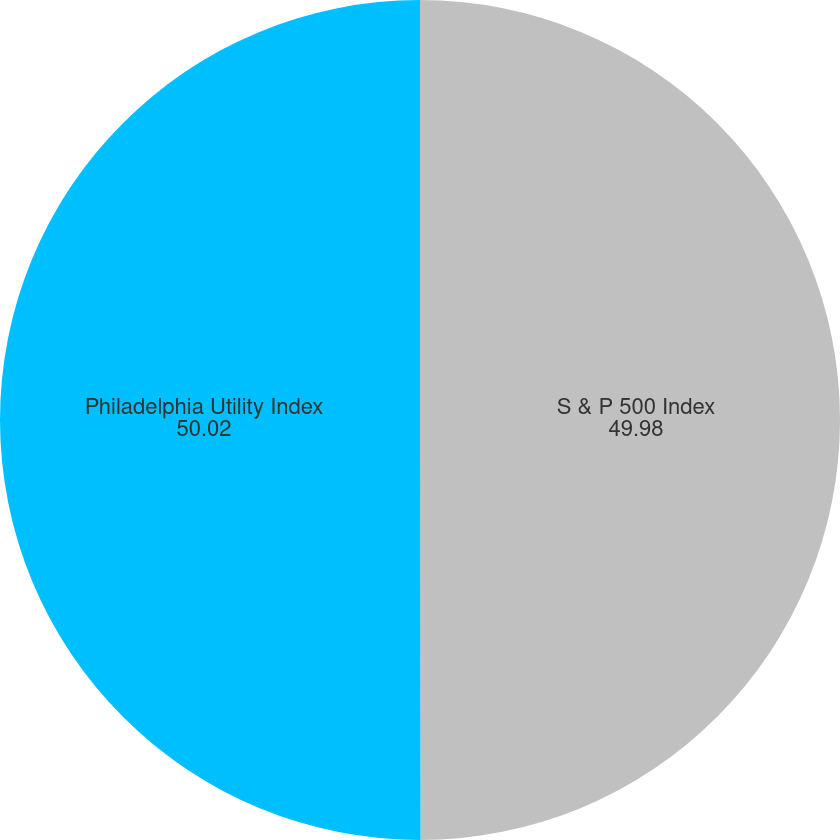Convert chart. <chart><loc_0><loc_0><loc_500><loc_500><pie_chart><fcel>S & P 500 Index<fcel>Philadelphia Utility Index<nl><fcel>49.98%<fcel>50.02%<nl></chart> 